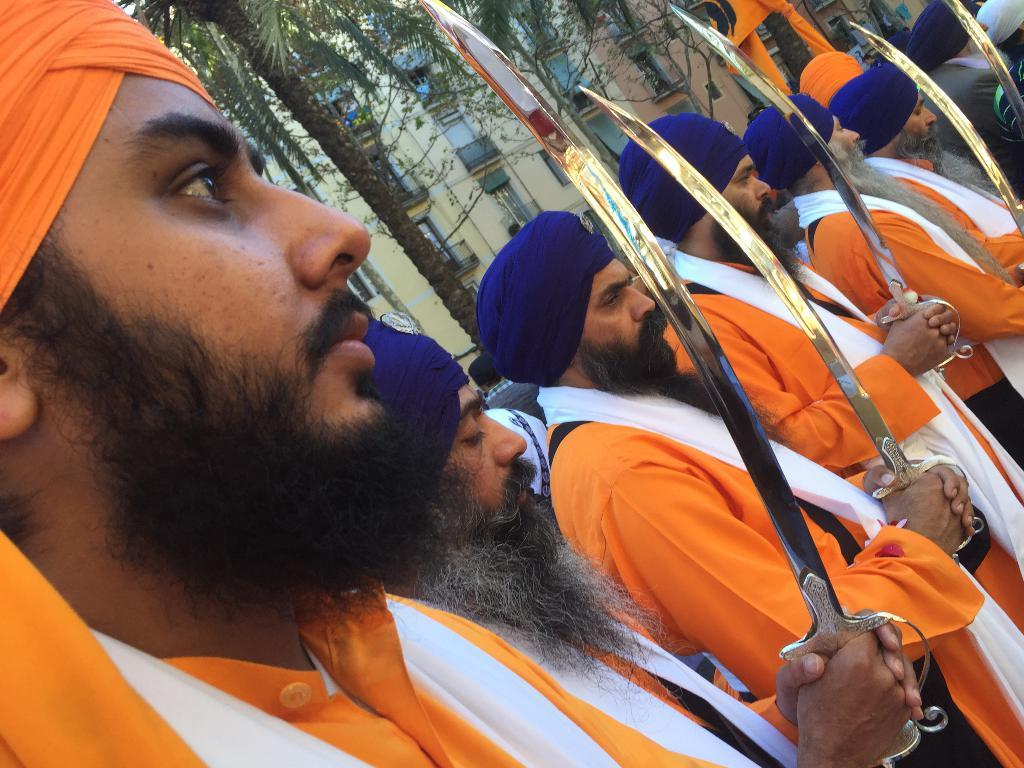How many people are in the image? There are persons standing in the image. What are the persons holding in the image? The persons are holding a sword. What can be seen in the background of the image? There are trees and a building in the background of the image. What type of cable is being used by the persons in the image? There is no cable visible in the image; the persons are holding a sword. Can you see any badges on the persons in the image? There is no mention of badges in the provided facts, so we cannot determine if any are present in the image. 